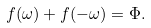<formula> <loc_0><loc_0><loc_500><loc_500>f ( \omega ) + f ( - \omega ) = \Phi .</formula> 